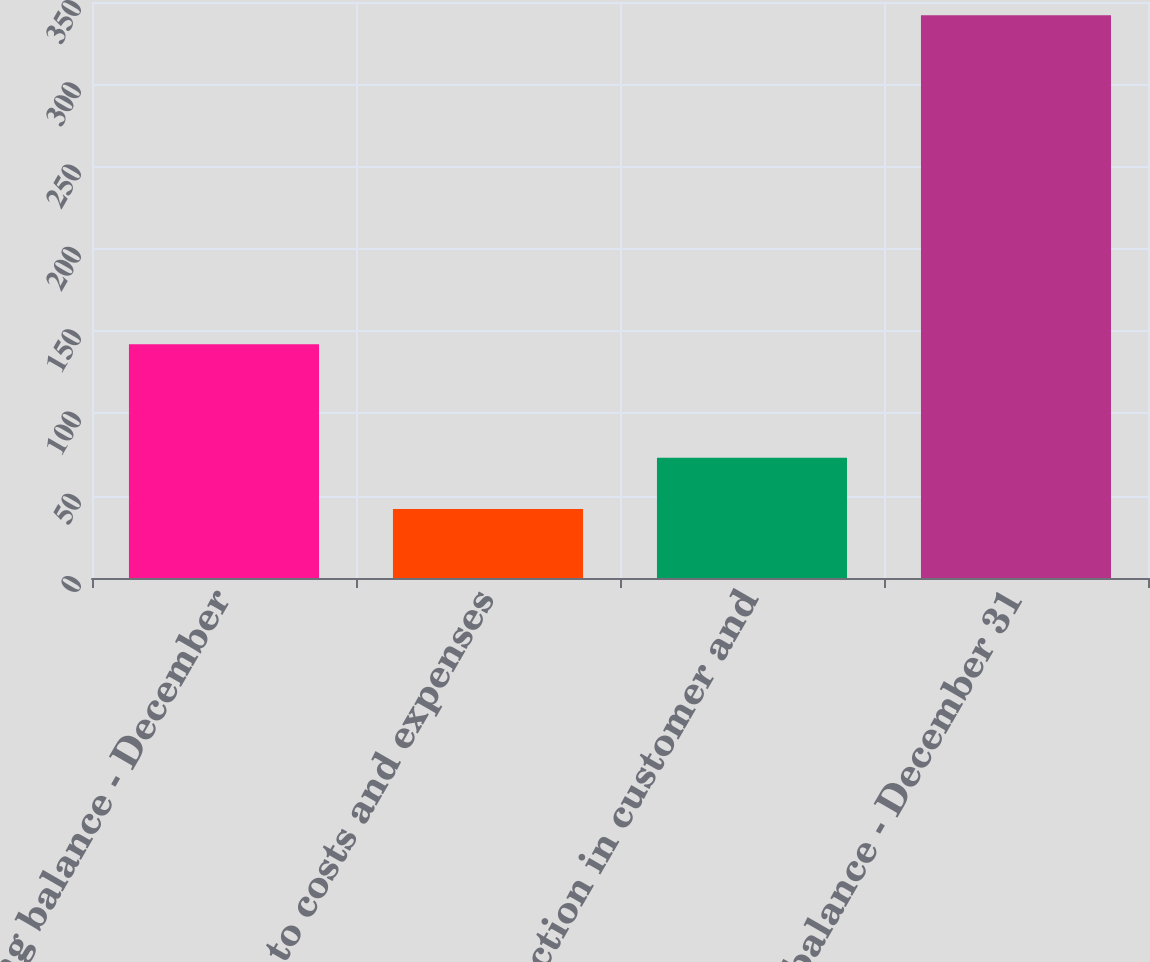Convert chart to OTSL. <chart><loc_0><loc_0><loc_500><loc_500><bar_chart><fcel>Beginning balance - December<fcel>Charged to costs and expenses<fcel>Reduction in customer and<fcel>Ending balance - December 31<nl><fcel>142<fcel>42<fcel>73<fcel>342<nl></chart> 